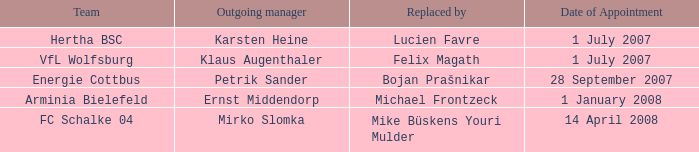When was the appointment date for VFL Wolfsburg? 1 July 2007. 